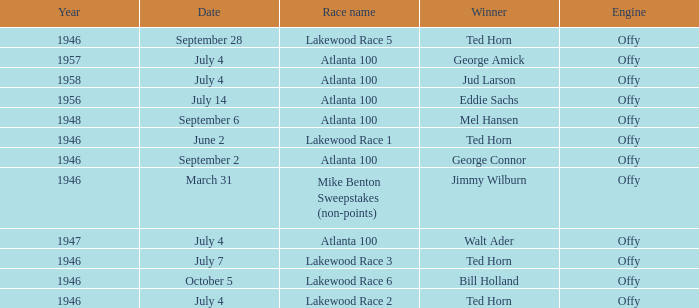What date did Ted Horn win Lakewood Race 2? July 4. 